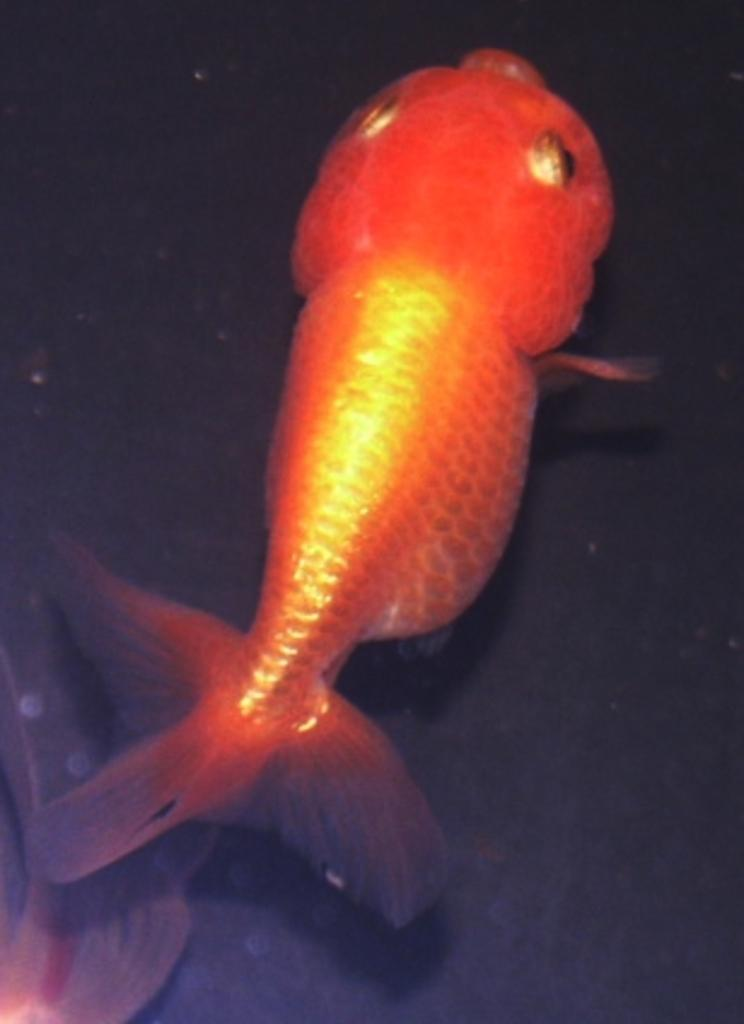What type of animal is in the image? There is a fish in the image. What can be observed about the background of the image? The background of the image is dark in color. What type of plastic material is visible in the image? There is no plastic material visible in the image; it only features a fish against a dark background. 